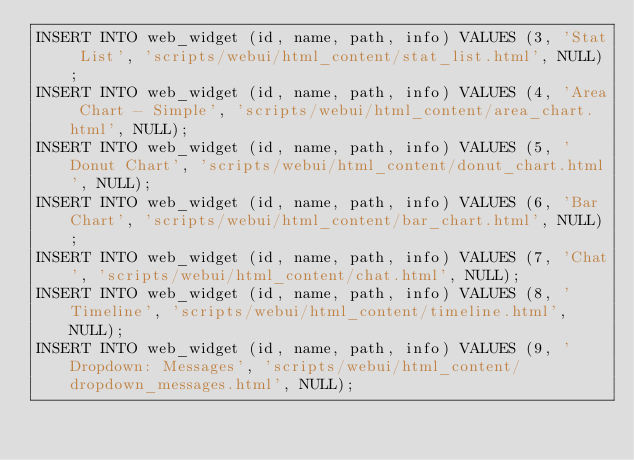Convert code to text. <code><loc_0><loc_0><loc_500><loc_500><_SQL_>INSERT INTO web_widget (id, name, path, info) VALUES (3, 'Stat List', 'scripts/webui/html_content/stat_list.html', NULL);
INSERT INTO web_widget (id, name, path, info) VALUES (4, 'Area Chart - Simple', 'scripts/webui/html_content/area_chart.html', NULL);
INSERT INTO web_widget (id, name, path, info) VALUES (5, 'Donut Chart', 'scripts/webui/html_content/donut_chart.html', NULL);
INSERT INTO web_widget (id, name, path, info) VALUES (6, 'Bar Chart', 'scripts/webui/html_content/bar_chart.html', NULL);
INSERT INTO web_widget (id, name, path, info) VALUES (7, 'Chat', 'scripts/webui/html_content/chat.html', NULL);
INSERT INTO web_widget (id, name, path, info) VALUES (8, 'Timeline', 'scripts/webui/html_content/timeline.html', NULL);
INSERT INTO web_widget (id, name, path, info) VALUES (9, 'Dropdown: Messages', 'scripts/webui/html_content/dropdown_messages.html', NULL);</code> 